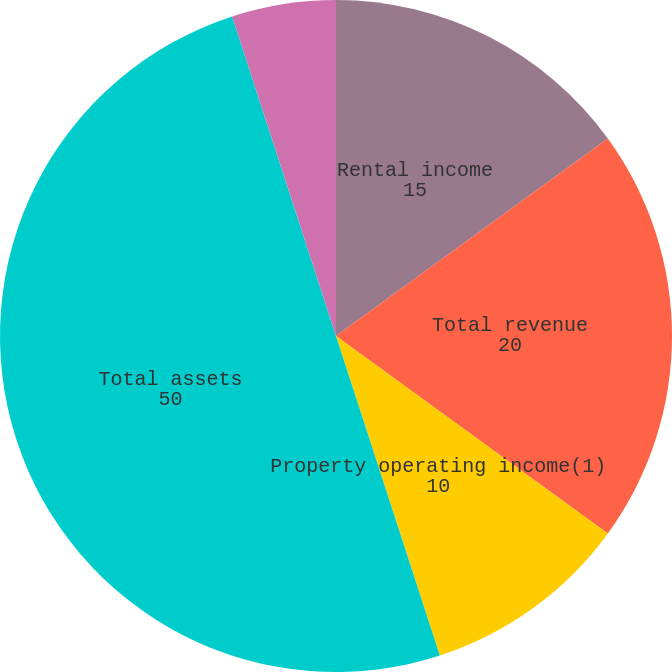<chart> <loc_0><loc_0><loc_500><loc_500><pie_chart><fcel>Rental income<fcel>Total revenue<fcel>Property operating income(1)<fcel>Property operating income as a<fcel>Total assets<fcel>Gross leasable square feet<nl><fcel>15.0%<fcel>20.0%<fcel>10.0%<fcel>0.0%<fcel>50.0%<fcel>5.0%<nl></chart> 